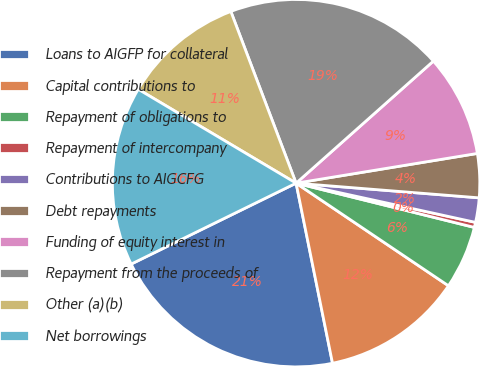<chart> <loc_0><loc_0><loc_500><loc_500><pie_chart><fcel>Loans to AIGFP for collateral<fcel>Capital contributions to<fcel>Repayment of obligations to<fcel>Repayment of intercompany<fcel>Contributions to AIGCFG<fcel>Debt repayments<fcel>Funding of equity interest in<fcel>Repayment from the proceeds of<fcel>Other (a)(b)<fcel>Net borrowings<nl><fcel>20.92%<fcel>12.39%<fcel>5.56%<fcel>0.45%<fcel>2.15%<fcel>3.86%<fcel>8.98%<fcel>19.21%<fcel>10.68%<fcel>15.8%<nl></chart> 